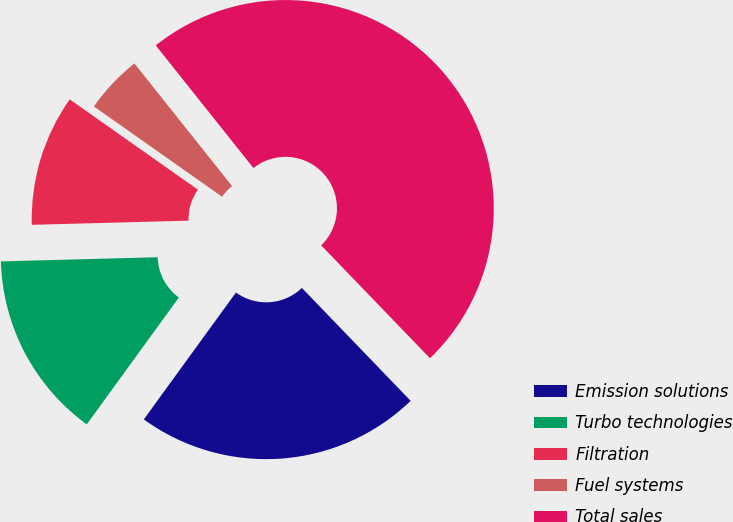<chart> <loc_0><loc_0><loc_500><loc_500><pie_chart><fcel>Emission solutions<fcel>Turbo technologies<fcel>Filtration<fcel>Fuel systems<fcel>Total sales<nl><fcel>22.2%<fcel>14.58%<fcel>10.19%<fcel>4.53%<fcel>48.5%<nl></chart> 